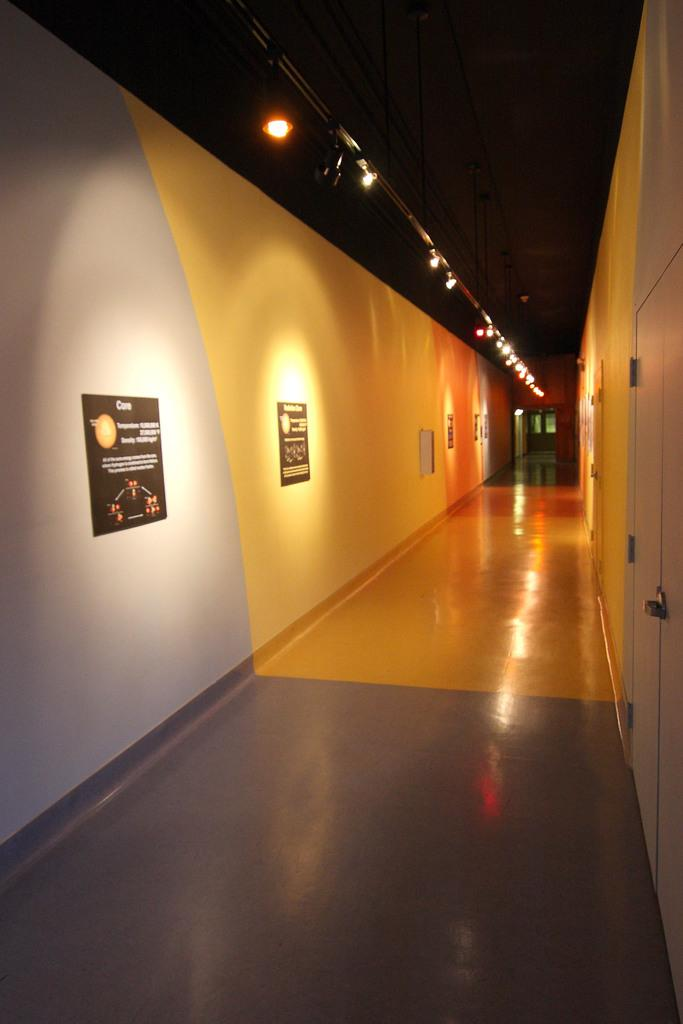What is located on the left side of the image? There are posters on the left side of the image. What can be seen on the posters? The posters have text written on them. What is on the right side of the image? There is a white door on the right side of the image. What is visible at the top of the image? There are lights at the top of the image. Can you see any caves in the image? There is no cave present in the image. Is there a guitar visible in the image? There is no guitar present in the image. 